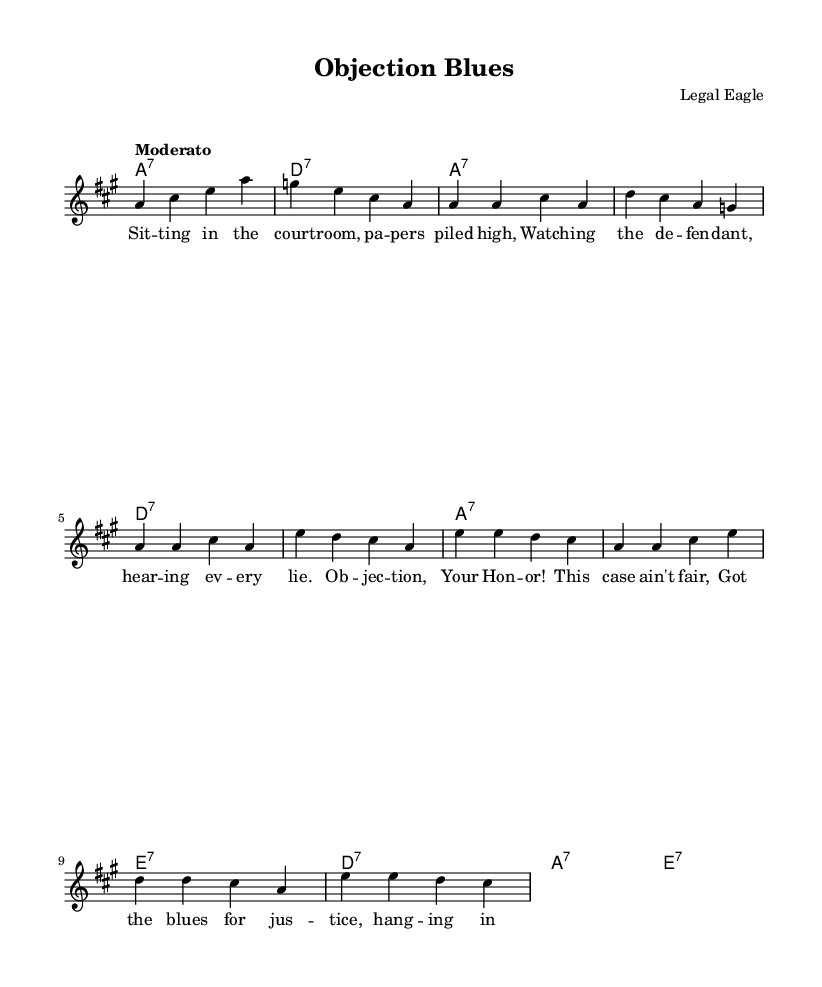What is the key signature of this music? The key signature is A major, which has three sharps: F sharp, C sharp, and G sharp.
Answer: A major What is the time signature of this piece? The time signature is 4/4, indicating four beats per measure, with a quarter note getting one beat.
Answer: 4/4 What is the tempo marking given in the sheet music? The tempo marking is "Moderato," which indicates a moderate pace or speed in the performance.
Answer: Moderato How many measures does the verse section contain? The verse section contains 8 measures, as indicated by the grouping of notes and the structure of the melody.
Answer: 8 measures What chord comes after the D7 chord in the harmonies? The chord that comes after the D7 chord is the A7 chord, as seen in the sequence of chord changes.
Answer: A7 What lyrical theme is presented in the chorus? The chorus presents a theme of objection to perceived unfairness in a legal setting, as reflected in the lines about "objection" and "justice."
Answer: Objection to unfairness What type of song is this reflecting? This song reflects a "Blues" type, which often discusses personal struggles, including themes of legal issues and courtroom drama.
Answer: Blues 